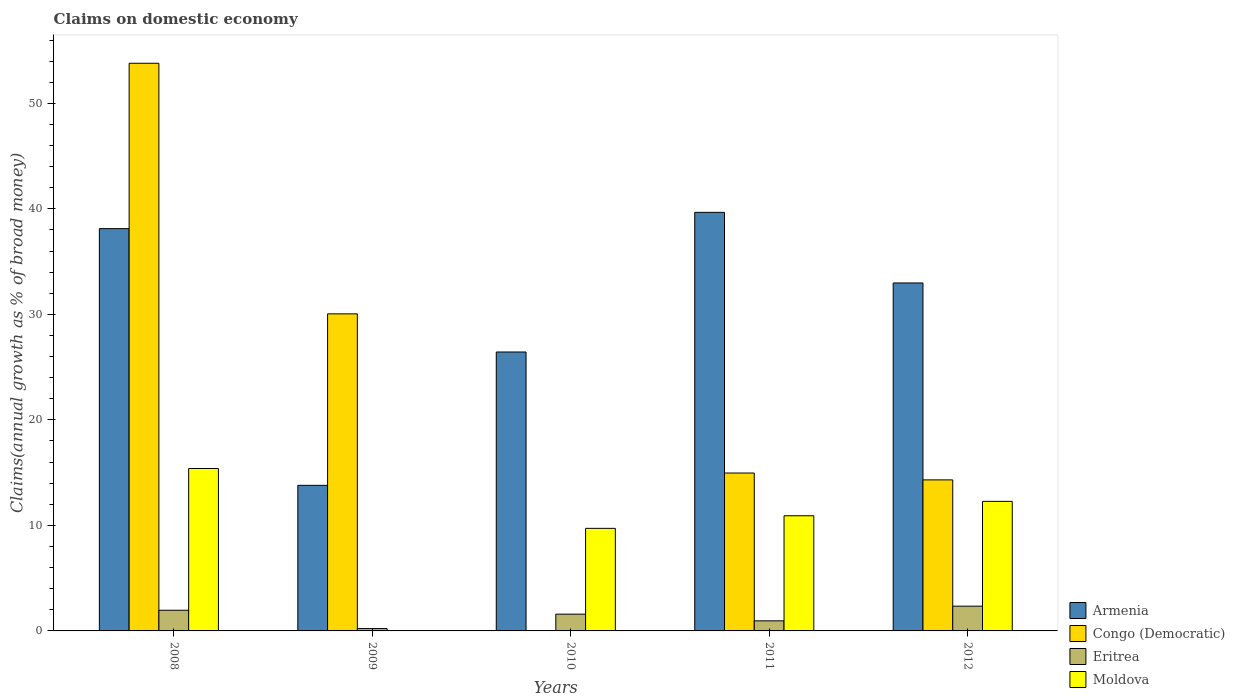Are the number of bars per tick equal to the number of legend labels?
Your answer should be compact. No. How many bars are there on the 1st tick from the left?
Provide a short and direct response. 4. How many bars are there on the 5th tick from the right?
Provide a succinct answer. 4. What is the label of the 5th group of bars from the left?
Make the answer very short. 2012. What is the percentage of broad money claimed on domestic economy in Armenia in 2010?
Keep it short and to the point. 26.43. Across all years, what is the maximum percentage of broad money claimed on domestic economy in Congo (Democratic)?
Your answer should be compact. 53.8. What is the total percentage of broad money claimed on domestic economy in Congo (Democratic) in the graph?
Offer a terse response. 113.12. What is the difference between the percentage of broad money claimed on domestic economy in Eritrea in 2009 and that in 2010?
Make the answer very short. -1.37. What is the difference between the percentage of broad money claimed on domestic economy in Moldova in 2010 and the percentage of broad money claimed on domestic economy in Eritrea in 2009?
Offer a terse response. 9.5. What is the average percentage of broad money claimed on domestic economy in Armenia per year?
Offer a very short reply. 30.2. In the year 2009, what is the difference between the percentage of broad money claimed on domestic economy in Armenia and percentage of broad money claimed on domestic economy in Congo (Democratic)?
Make the answer very short. -16.25. In how many years, is the percentage of broad money claimed on domestic economy in Eritrea greater than 46 %?
Your response must be concise. 0. What is the ratio of the percentage of broad money claimed on domestic economy in Congo (Democratic) in 2008 to that in 2011?
Offer a very short reply. 3.6. Is the percentage of broad money claimed on domestic economy in Eritrea in 2010 less than that in 2012?
Provide a succinct answer. Yes. What is the difference between the highest and the second highest percentage of broad money claimed on domestic economy in Armenia?
Make the answer very short. 1.54. What is the difference between the highest and the lowest percentage of broad money claimed on domestic economy in Eritrea?
Keep it short and to the point. 2.12. In how many years, is the percentage of broad money claimed on domestic economy in Eritrea greater than the average percentage of broad money claimed on domestic economy in Eritrea taken over all years?
Keep it short and to the point. 3. Is the sum of the percentage of broad money claimed on domestic economy in Congo (Democratic) in 2008 and 2012 greater than the maximum percentage of broad money claimed on domestic economy in Eritrea across all years?
Your answer should be very brief. Yes. Is it the case that in every year, the sum of the percentage of broad money claimed on domestic economy in Eritrea and percentage of broad money claimed on domestic economy in Moldova is greater than the sum of percentage of broad money claimed on domestic economy in Armenia and percentage of broad money claimed on domestic economy in Congo (Democratic)?
Give a very brief answer. No. Are all the bars in the graph horizontal?
Keep it short and to the point. No. What is the difference between two consecutive major ticks on the Y-axis?
Provide a succinct answer. 10. Where does the legend appear in the graph?
Give a very brief answer. Bottom right. How many legend labels are there?
Keep it short and to the point. 4. What is the title of the graph?
Give a very brief answer. Claims on domestic economy. Does "High income: OECD" appear as one of the legend labels in the graph?
Your response must be concise. No. What is the label or title of the X-axis?
Your answer should be compact. Years. What is the label or title of the Y-axis?
Make the answer very short. Claims(annual growth as % of broad money). What is the Claims(annual growth as % of broad money) of Armenia in 2008?
Give a very brief answer. 38.12. What is the Claims(annual growth as % of broad money) of Congo (Democratic) in 2008?
Keep it short and to the point. 53.8. What is the Claims(annual growth as % of broad money) of Eritrea in 2008?
Offer a very short reply. 1.96. What is the Claims(annual growth as % of broad money) of Moldova in 2008?
Provide a succinct answer. 15.39. What is the Claims(annual growth as % of broad money) of Armenia in 2009?
Offer a terse response. 13.8. What is the Claims(annual growth as % of broad money) of Congo (Democratic) in 2009?
Offer a terse response. 30.05. What is the Claims(annual growth as % of broad money) in Eritrea in 2009?
Your response must be concise. 0.22. What is the Claims(annual growth as % of broad money) in Moldova in 2009?
Ensure brevity in your answer.  0. What is the Claims(annual growth as % of broad money) in Armenia in 2010?
Your answer should be very brief. 26.43. What is the Claims(annual growth as % of broad money) in Congo (Democratic) in 2010?
Make the answer very short. 0. What is the Claims(annual growth as % of broad money) in Eritrea in 2010?
Ensure brevity in your answer.  1.59. What is the Claims(annual growth as % of broad money) of Moldova in 2010?
Offer a terse response. 9.72. What is the Claims(annual growth as % of broad money) of Armenia in 2011?
Ensure brevity in your answer.  39.67. What is the Claims(annual growth as % of broad money) of Congo (Democratic) in 2011?
Ensure brevity in your answer.  14.96. What is the Claims(annual growth as % of broad money) of Eritrea in 2011?
Keep it short and to the point. 0.96. What is the Claims(annual growth as % of broad money) in Moldova in 2011?
Give a very brief answer. 10.91. What is the Claims(annual growth as % of broad money) of Armenia in 2012?
Provide a succinct answer. 32.98. What is the Claims(annual growth as % of broad money) of Congo (Democratic) in 2012?
Your answer should be compact. 14.31. What is the Claims(annual growth as % of broad money) in Eritrea in 2012?
Make the answer very short. 2.35. What is the Claims(annual growth as % of broad money) in Moldova in 2012?
Make the answer very short. 12.28. Across all years, what is the maximum Claims(annual growth as % of broad money) in Armenia?
Provide a short and direct response. 39.67. Across all years, what is the maximum Claims(annual growth as % of broad money) of Congo (Democratic)?
Keep it short and to the point. 53.8. Across all years, what is the maximum Claims(annual growth as % of broad money) of Eritrea?
Make the answer very short. 2.35. Across all years, what is the maximum Claims(annual growth as % of broad money) in Moldova?
Your answer should be very brief. 15.39. Across all years, what is the minimum Claims(annual growth as % of broad money) of Armenia?
Make the answer very short. 13.8. Across all years, what is the minimum Claims(annual growth as % of broad money) of Congo (Democratic)?
Offer a terse response. 0. Across all years, what is the minimum Claims(annual growth as % of broad money) in Eritrea?
Offer a very short reply. 0.22. What is the total Claims(annual growth as % of broad money) in Armenia in the graph?
Your answer should be compact. 151. What is the total Claims(annual growth as % of broad money) in Congo (Democratic) in the graph?
Give a very brief answer. 113.12. What is the total Claims(annual growth as % of broad money) of Eritrea in the graph?
Your answer should be compact. 7.07. What is the total Claims(annual growth as % of broad money) in Moldova in the graph?
Keep it short and to the point. 48.3. What is the difference between the Claims(annual growth as % of broad money) of Armenia in 2008 and that in 2009?
Your answer should be very brief. 24.33. What is the difference between the Claims(annual growth as % of broad money) of Congo (Democratic) in 2008 and that in 2009?
Your answer should be compact. 23.75. What is the difference between the Claims(annual growth as % of broad money) of Eritrea in 2008 and that in 2009?
Ensure brevity in your answer.  1.74. What is the difference between the Claims(annual growth as % of broad money) in Armenia in 2008 and that in 2010?
Your answer should be very brief. 11.69. What is the difference between the Claims(annual growth as % of broad money) in Eritrea in 2008 and that in 2010?
Ensure brevity in your answer.  0.37. What is the difference between the Claims(annual growth as % of broad money) in Moldova in 2008 and that in 2010?
Make the answer very short. 5.67. What is the difference between the Claims(annual growth as % of broad money) in Armenia in 2008 and that in 2011?
Give a very brief answer. -1.54. What is the difference between the Claims(annual growth as % of broad money) in Congo (Democratic) in 2008 and that in 2011?
Ensure brevity in your answer.  38.83. What is the difference between the Claims(annual growth as % of broad money) of Moldova in 2008 and that in 2011?
Provide a succinct answer. 4.48. What is the difference between the Claims(annual growth as % of broad money) in Armenia in 2008 and that in 2012?
Your answer should be compact. 5.15. What is the difference between the Claims(annual growth as % of broad money) in Congo (Democratic) in 2008 and that in 2012?
Keep it short and to the point. 39.48. What is the difference between the Claims(annual growth as % of broad money) in Eritrea in 2008 and that in 2012?
Provide a succinct answer. -0.39. What is the difference between the Claims(annual growth as % of broad money) in Moldova in 2008 and that in 2012?
Your answer should be very brief. 3.11. What is the difference between the Claims(annual growth as % of broad money) of Armenia in 2009 and that in 2010?
Your answer should be very brief. -12.64. What is the difference between the Claims(annual growth as % of broad money) in Eritrea in 2009 and that in 2010?
Keep it short and to the point. -1.37. What is the difference between the Claims(annual growth as % of broad money) in Armenia in 2009 and that in 2011?
Give a very brief answer. -25.87. What is the difference between the Claims(annual growth as % of broad money) of Congo (Democratic) in 2009 and that in 2011?
Your answer should be very brief. 15.08. What is the difference between the Claims(annual growth as % of broad money) of Eritrea in 2009 and that in 2011?
Provide a short and direct response. -0.73. What is the difference between the Claims(annual growth as % of broad money) of Armenia in 2009 and that in 2012?
Your response must be concise. -19.18. What is the difference between the Claims(annual growth as % of broad money) of Congo (Democratic) in 2009 and that in 2012?
Give a very brief answer. 15.73. What is the difference between the Claims(annual growth as % of broad money) of Eritrea in 2009 and that in 2012?
Your answer should be very brief. -2.12. What is the difference between the Claims(annual growth as % of broad money) of Armenia in 2010 and that in 2011?
Your answer should be compact. -13.23. What is the difference between the Claims(annual growth as % of broad money) of Eritrea in 2010 and that in 2011?
Provide a short and direct response. 0.63. What is the difference between the Claims(annual growth as % of broad money) in Moldova in 2010 and that in 2011?
Your answer should be very brief. -1.19. What is the difference between the Claims(annual growth as % of broad money) in Armenia in 2010 and that in 2012?
Provide a short and direct response. -6.54. What is the difference between the Claims(annual growth as % of broad money) of Eritrea in 2010 and that in 2012?
Your answer should be compact. -0.76. What is the difference between the Claims(annual growth as % of broad money) of Moldova in 2010 and that in 2012?
Give a very brief answer. -2.56. What is the difference between the Claims(annual growth as % of broad money) in Armenia in 2011 and that in 2012?
Offer a terse response. 6.69. What is the difference between the Claims(annual growth as % of broad money) in Congo (Democratic) in 2011 and that in 2012?
Your answer should be compact. 0.65. What is the difference between the Claims(annual growth as % of broad money) of Eritrea in 2011 and that in 2012?
Make the answer very short. -1.39. What is the difference between the Claims(annual growth as % of broad money) in Moldova in 2011 and that in 2012?
Ensure brevity in your answer.  -1.36. What is the difference between the Claims(annual growth as % of broad money) in Armenia in 2008 and the Claims(annual growth as % of broad money) in Congo (Democratic) in 2009?
Your answer should be very brief. 8.08. What is the difference between the Claims(annual growth as % of broad money) in Armenia in 2008 and the Claims(annual growth as % of broad money) in Eritrea in 2009?
Provide a succinct answer. 37.9. What is the difference between the Claims(annual growth as % of broad money) of Congo (Democratic) in 2008 and the Claims(annual growth as % of broad money) of Eritrea in 2009?
Provide a short and direct response. 53.57. What is the difference between the Claims(annual growth as % of broad money) of Armenia in 2008 and the Claims(annual growth as % of broad money) of Eritrea in 2010?
Provide a short and direct response. 36.54. What is the difference between the Claims(annual growth as % of broad money) of Armenia in 2008 and the Claims(annual growth as % of broad money) of Moldova in 2010?
Make the answer very short. 28.4. What is the difference between the Claims(annual growth as % of broad money) in Congo (Democratic) in 2008 and the Claims(annual growth as % of broad money) in Eritrea in 2010?
Your answer should be very brief. 52.21. What is the difference between the Claims(annual growth as % of broad money) in Congo (Democratic) in 2008 and the Claims(annual growth as % of broad money) in Moldova in 2010?
Make the answer very short. 44.08. What is the difference between the Claims(annual growth as % of broad money) of Eritrea in 2008 and the Claims(annual growth as % of broad money) of Moldova in 2010?
Make the answer very short. -7.76. What is the difference between the Claims(annual growth as % of broad money) of Armenia in 2008 and the Claims(annual growth as % of broad money) of Congo (Democratic) in 2011?
Your response must be concise. 23.16. What is the difference between the Claims(annual growth as % of broad money) in Armenia in 2008 and the Claims(annual growth as % of broad money) in Eritrea in 2011?
Give a very brief answer. 37.17. What is the difference between the Claims(annual growth as % of broad money) of Armenia in 2008 and the Claims(annual growth as % of broad money) of Moldova in 2011?
Make the answer very short. 27.21. What is the difference between the Claims(annual growth as % of broad money) in Congo (Democratic) in 2008 and the Claims(annual growth as % of broad money) in Eritrea in 2011?
Ensure brevity in your answer.  52.84. What is the difference between the Claims(annual growth as % of broad money) of Congo (Democratic) in 2008 and the Claims(annual growth as % of broad money) of Moldova in 2011?
Offer a terse response. 42.88. What is the difference between the Claims(annual growth as % of broad money) of Eritrea in 2008 and the Claims(annual growth as % of broad money) of Moldova in 2011?
Offer a very short reply. -8.96. What is the difference between the Claims(annual growth as % of broad money) of Armenia in 2008 and the Claims(annual growth as % of broad money) of Congo (Democratic) in 2012?
Keep it short and to the point. 23.81. What is the difference between the Claims(annual growth as % of broad money) of Armenia in 2008 and the Claims(annual growth as % of broad money) of Eritrea in 2012?
Keep it short and to the point. 35.78. What is the difference between the Claims(annual growth as % of broad money) in Armenia in 2008 and the Claims(annual growth as % of broad money) in Moldova in 2012?
Keep it short and to the point. 25.85. What is the difference between the Claims(annual growth as % of broad money) in Congo (Democratic) in 2008 and the Claims(annual growth as % of broad money) in Eritrea in 2012?
Your answer should be very brief. 51.45. What is the difference between the Claims(annual growth as % of broad money) in Congo (Democratic) in 2008 and the Claims(annual growth as % of broad money) in Moldova in 2012?
Ensure brevity in your answer.  41.52. What is the difference between the Claims(annual growth as % of broad money) in Eritrea in 2008 and the Claims(annual growth as % of broad money) in Moldova in 2012?
Make the answer very short. -10.32. What is the difference between the Claims(annual growth as % of broad money) of Armenia in 2009 and the Claims(annual growth as % of broad money) of Eritrea in 2010?
Your answer should be very brief. 12.21. What is the difference between the Claims(annual growth as % of broad money) in Armenia in 2009 and the Claims(annual growth as % of broad money) in Moldova in 2010?
Keep it short and to the point. 4.08. What is the difference between the Claims(annual growth as % of broad money) of Congo (Democratic) in 2009 and the Claims(annual growth as % of broad money) of Eritrea in 2010?
Ensure brevity in your answer.  28.46. What is the difference between the Claims(annual growth as % of broad money) of Congo (Democratic) in 2009 and the Claims(annual growth as % of broad money) of Moldova in 2010?
Your answer should be compact. 20.33. What is the difference between the Claims(annual growth as % of broad money) in Eritrea in 2009 and the Claims(annual growth as % of broad money) in Moldova in 2010?
Provide a short and direct response. -9.5. What is the difference between the Claims(annual growth as % of broad money) in Armenia in 2009 and the Claims(annual growth as % of broad money) in Congo (Democratic) in 2011?
Your response must be concise. -1.17. What is the difference between the Claims(annual growth as % of broad money) of Armenia in 2009 and the Claims(annual growth as % of broad money) of Eritrea in 2011?
Your answer should be compact. 12.84. What is the difference between the Claims(annual growth as % of broad money) of Armenia in 2009 and the Claims(annual growth as % of broad money) of Moldova in 2011?
Your response must be concise. 2.88. What is the difference between the Claims(annual growth as % of broad money) of Congo (Democratic) in 2009 and the Claims(annual growth as % of broad money) of Eritrea in 2011?
Provide a short and direct response. 29.09. What is the difference between the Claims(annual growth as % of broad money) in Congo (Democratic) in 2009 and the Claims(annual growth as % of broad money) in Moldova in 2011?
Offer a very short reply. 19.13. What is the difference between the Claims(annual growth as % of broad money) of Eritrea in 2009 and the Claims(annual growth as % of broad money) of Moldova in 2011?
Provide a short and direct response. -10.69. What is the difference between the Claims(annual growth as % of broad money) in Armenia in 2009 and the Claims(annual growth as % of broad money) in Congo (Democratic) in 2012?
Offer a very short reply. -0.52. What is the difference between the Claims(annual growth as % of broad money) in Armenia in 2009 and the Claims(annual growth as % of broad money) in Eritrea in 2012?
Your response must be concise. 11.45. What is the difference between the Claims(annual growth as % of broad money) of Armenia in 2009 and the Claims(annual growth as % of broad money) of Moldova in 2012?
Your answer should be compact. 1.52. What is the difference between the Claims(annual growth as % of broad money) of Congo (Democratic) in 2009 and the Claims(annual growth as % of broad money) of Eritrea in 2012?
Your answer should be compact. 27.7. What is the difference between the Claims(annual growth as % of broad money) of Congo (Democratic) in 2009 and the Claims(annual growth as % of broad money) of Moldova in 2012?
Provide a succinct answer. 17.77. What is the difference between the Claims(annual growth as % of broad money) in Eritrea in 2009 and the Claims(annual growth as % of broad money) in Moldova in 2012?
Provide a short and direct response. -12.05. What is the difference between the Claims(annual growth as % of broad money) in Armenia in 2010 and the Claims(annual growth as % of broad money) in Congo (Democratic) in 2011?
Offer a terse response. 11.47. What is the difference between the Claims(annual growth as % of broad money) of Armenia in 2010 and the Claims(annual growth as % of broad money) of Eritrea in 2011?
Ensure brevity in your answer.  25.48. What is the difference between the Claims(annual growth as % of broad money) in Armenia in 2010 and the Claims(annual growth as % of broad money) in Moldova in 2011?
Ensure brevity in your answer.  15.52. What is the difference between the Claims(annual growth as % of broad money) in Eritrea in 2010 and the Claims(annual growth as % of broad money) in Moldova in 2011?
Ensure brevity in your answer.  -9.32. What is the difference between the Claims(annual growth as % of broad money) in Armenia in 2010 and the Claims(annual growth as % of broad money) in Congo (Democratic) in 2012?
Your answer should be very brief. 12.12. What is the difference between the Claims(annual growth as % of broad money) in Armenia in 2010 and the Claims(annual growth as % of broad money) in Eritrea in 2012?
Provide a succinct answer. 24.09. What is the difference between the Claims(annual growth as % of broad money) of Armenia in 2010 and the Claims(annual growth as % of broad money) of Moldova in 2012?
Your response must be concise. 14.16. What is the difference between the Claims(annual growth as % of broad money) in Eritrea in 2010 and the Claims(annual growth as % of broad money) in Moldova in 2012?
Your response must be concise. -10.69. What is the difference between the Claims(annual growth as % of broad money) in Armenia in 2011 and the Claims(annual growth as % of broad money) in Congo (Democratic) in 2012?
Give a very brief answer. 25.35. What is the difference between the Claims(annual growth as % of broad money) of Armenia in 2011 and the Claims(annual growth as % of broad money) of Eritrea in 2012?
Ensure brevity in your answer.  37.32. What is the difference between the Claims(annual growth as % of broad money) of Armenia in 2011 and the Claims(annual growth as % of broad money) of Moldova in 2012?
Give a very brief answer. 27.39. What is the difference between the Claims(annual growth as % of broad money) in Congo (Democratic) in 2011 and the Claims(annual growth as % of broad money) in Eritrea in 2012?
Ensure brevity in your answer.  12.62. What is the difference between the Claims(annual growth as % of broad money) of Congo (Democratic) in 2011 and the Claims(annual growth as % of broad money) of Moldova in 2012?
Your answer should be very brief. 2.69. What is the difference between the Claims(annual growth as % of broad money) of Eritrea in 2011 and the Claims(annual growth as % of broad money) of Moldova in 2012?
Your response must be concise. -11.32. What is the average Claims(annual growth as % of broad money) in Armenia per year?
Provide a short and direct response. 30.2. What is the average Claims(annual growth as % of broad money) in Congo (Democratic) per year?
Provide a succinct answer. 22.62. What is the average Claims(annual growth as % of broad money) of Eritrea per year?
Offer a very short reply. 1.41. What is the average Claims(annual growth as % of broad money) in Moldova per year?
Provide a short and direct response. 9.66. In the year 2008, what is the difference between the Claims(annual growth as % of broad money) of Armenia and Claims(annual growth as % of broad money) of Congo (Democratic)?
Provide a short and direct response. -15.67. In the year 2008, what is the difference between the Claims(annual growth as % of broad money) of Armenia and Claims(annual growth as % of broad money) of Eritrea?
Offer a terse response. 36.17. In the year 2008, what is the difference between the Claims(annual growth as % of broad money) of Armenia and Claims(annual growth as % of broad money) of Moldova?
Your answer should be compact. 22.73. In the year 2008, what is the difference between the Claims(annual growth as % of broad money) in Congo (Democratic) and Claims(annual growth as % of broad money) in Eritrea?
Ensure brevity in your answer.  51.84. In the year 2008, what is the difference between the Claims(annual growth as % of broad money) of Congo (Democratic) and Claims(annual growth as % of broad money) of Moldova?
Your answer should be very brief. 38.41. In the year 2008, what is the difference between the Claims(annual growth as % of broad money) of Eritrea and Claims(annual growth as % of broad money) of Moldova?
Provide a short and direct response. -13.43. In the year 2009, what is the difference between the Claims(annual growth as % of broad money) in Armenia and Claims(annual growth as % of broad money) in Congo (Democratic)?
Ensure brevity in your answer.  -16.25. In the year 2009, what is the difference between the Claims(annual growth as % of broad money) in Armenia and Claims(annual growth as % of broad money) in Eritrea?
Offer a terse response. 13.57. In the year 2009, what is the difference between the Claims(annual growth as % of broad money) in Congo (Democratic) and Claims(annual growth as % of broad money) in Eritrea?
Your answer should be very brief. 29.82. In the year 2010, what is the difference between the Claims(annual growth as % of broad money) in Armenia and Claims(annual growth as % of broad money) in Eritrea?
Your response must be concise. 24.84. In the year 2010, what is the difference between the Claims(annual growth as % of broad money) of Armenia and Claims(annual growth as % of broad money) of Moldova?
Your answer should be compact. 16.71. In the year 2010, what is the difference between the Claims(annual growth as % of broad money) in Eritrea and Claims(annual growth as % of broad money) in Moldova?
Offer a terse response. -8.13. In the year 2011, what is the difference between the Claims(annual growth as % of broad money) of Armenia and Claims(annual growth as % of broad money) of Congo (Democratic)?
Your answer should be very brief. 24.7. In the year 2011, what is the difference between the Claims(annual growth as % of broad money) in Armenia and Claims(annual growth as % of broad money) in Eritrea?
Keep it short and to the point. 38.71. In the year 2011, what is the difference between the Claims(annual growth as % of broad money) of Armenia and Claims(annual growth as % of broad money) of Moldova?
Your response must be concise. 28.75. In the year 2011, what is the difference between the Claims(annual growth as % of broad money) in Congo (Democratic) and Claims(annual growth as % of broad money) in Eritrea?
Provide a short and direct response. 14.01. In the year 2011, what is the difference between the Claims(annual growth as % of broad money) in Congo (Democratic) and Claims(annual growth as % of broad money) in Moldova?
Your answer should be compact. 4.05. In the year 2011, what is the difference between the Claims(annual growth as % of broad money) of Eritrea and Claims(annual growth as % of broad money) of Moldova?
Your response must be concise. -9.96. In the year 2012, what is the difference between the Claims(annual growth as % of broad money) in Armenia and Claims(annual growth as % of broad money) in Congo (Democratic)?
Give a very brief answer. 18.66. In the year 2012, what is the difference between the Claims(annual growth as % of broad money) of Armenia and Claims(annual growth as % of broad money) of Eritrea?
Your response must be concise. 30.63. In the year 2012, what is the difference between the Claims(annual growth as % of broad money) of Armenia and Claims(annual growth as % of broad money) of Moldova?
Give a very brief answer. 20.7. In the year 2012, what is the difference between the Claims(annual growth as % of broad money) of Congo (Democratic) and Claims(annual growth as % of broad money) of Eritrea?
Ensure brevity in your answer.  11.97. In the year 2012, what is the difference between the Claims(annual growth as % of broad money) of Congo (Democratic) and Claims(annual growth as % of broad money) of Moldova?
Offer a very short reply. 2.04. In the year 2012, what is the difference between the Claims(annual growth as % of broad money) in Eritrea and Claims(annual growth as % of broad money) in Moldova?
Give a very brief answer. -9.93. What is the ratio of the Claims(annual growth as % of broad money) in Armenia in 2008 to that in 2009?
Keep it short and to the point. 2.76. What is the ratio of the Claims(annual growth as % of broad money) of Congo (Democratic) in 2008 to that in 2009?
Ensure brevity in your answer.  1.79. What is the ratio of the Claims(annual growth as % of broad money) of Eritrea in 2008 to that in 2009?
Give a very brief answer. 8.77. What is the ratio of the Claims(annual growth as % of broad money) of Armenia in 2008 to that in 2010?
Provide a short and direct response. 1.44. What is the ratio of the Claims(annual growth as % of broad money) in Eritrea in 2008 to that in 2010?
Provide a short and direct response. 1.23. What is the ratio of the Claims(annual growth as % of broad money) of Moldova in 2008 to that in 2010?
Provide a short and direct response. 1.58. What is the ratio of the Claims(annual growth as % of broad money) in Armenia in 2008 to that in 2011?
Your answer should be compact. 0.96. What is the ratio of the Claims(annual growth as % of broad money) in Congo (Democratic) in 2008 to that in 2011?
Your answer should be compact. 3.6. What is the ratio of the Claims(annual growth as % of broad money) in Eritrea in 2008 to that in 2011?
Your answer should be very brief. 2.05. What is the ratio of the Claims(annual growth as % of broad money) in Moldova in 2008 to that in 2011?
Keep it short and to the point. 1.41. What is the ratio of the Claims(annual growth as % of broad money) of Armenia in 2008 to that in 2012?
Offer a terse response. 1.16. What is the ratio of the Claims(annual growth as % of broad money) in Congo (Democratic) in 2008 to that in 2012?
Offer a terse response. 3.76. What is the ratio of the Claims(annual growth as % of broad money) of Eritrea in 2008 to that in 2012?
Your answer should be very brief. 0.83. What is the ratio of the Claims(annual growth as % of broad money) of Moldova in 2008 to that in 2012?
Your answer should be very brief. 1.25. What is the ratio of the Claims(annual growth as % of broad money) of Armenia in 2009 to that in 2010?
Your response must be concise. 0.52. What is the ratio of the Claims(annual growth as % of broad money) of Eritrea in 2009 to that in 2010?
Your response must be concise. 0.14. What is the ratio of the Claims(annual growth as % of broad money) of Armenia in 2009 to that in 2011?
Keep it short and to the point. 0.35. What is the ratio of the Claims(annual growth as % of broad money) in Congo (Democratic) in 2009 to that in 2011?
Provide a succinct answer. 2.01. What is the ratio of the Claims(annual growth as % of broad money) of Eritrea in 2009 to that in 2011?
Keep it short and to the point. 0.23. What is the ratio of the Claims(annual growth as % of broad money) in Armenia in 2009 to that in 2012?
Keep it short and to the point. 0.42. What is the ratio of the Claims(annual growth as % of broad money) of Congo (Democratic) in 2009 to that in 2012?
Keep it short and to the point. 2.1. What is the ratio of the Claims(annual growth as % of broad money) of Eritrea in 2009 to that in 2012?
Ensure brevity in your answer.  0.1. What is the ratio of the Claims(annual growth as % of broad money) of Armenia in 2010 to that in 2011?
Give a very brief answer. 0.67. What is the ratio of the Claims(annual growth as % of broad money) in Eritrea in 2010 to that in 2011?
Keep it short and to the point. 1.66. What is the ratio of the Claims(annual growth as % of broad money) of Moldova in 2010 to that in 2011?
Your response must be concise. 0.89. What is the ratio of the Claims(annual growth as % of broad money) of Armenia in 2010 to that in 2012?
Provide a succinct answer. 0.8. What is the ratio of the Claims(annual growth as % of broad money) of Eritrea in 2010 to that in 2012?
Provide a short and direct response. 0.68. What is the ratio of the Claims(annual growth as % of broad money) in Moldova in 2010 to that in 2012?
Offer a terse response. 0.79. What is the ratio of the Claims(annual growth as % of broad money) of Armenia in 2011 to that in 2012?
Make the answer very short. 1.2. What is the ratio of the Claims(annual growth as % of broad money) of Congo (Democratic) in 2011 to that in 2012?
Provide a short and direct response. 1.05. What is the ratio of the Claims(annual growth as % of broad money) of Eritrea in 2011 to that in 2012?
Make the answer very short. 0.41. What is the ratio of the Claims(annual growth as % of broad money) of Moldova in 2011 to that in 2012?
Your answer should be very brief. 0.89. What is the difference between the highest and the second highest Claims(annual growth as % of broad money) of Armenia?
Your answer should be very brief. 1.54. What is the difference between the highest and the second highest Claims(annual growth as % of broad money) in Congo (Democratic)?
Give a very brief answer. 23.75. What is the difference between the highest and the second highest Claims(annual growth as % of broad money) in Eritrea?
Provide a short and direct response. 0.39. What is the difference between the highest and the second highest Claims(annual growth as % of broad money) of Moldova?
Your answer should be compact. 3.11. What is the difference between the highest and the lowest Claims(annual growth as % of broad money) of Armenia?
Keep it short and to the point. 25.87. What is the difference between the highest and the lowest Claims(annual growth as % of broad money) in Congo (Democratic)?
Ensure brevity in your answer.  53.8. What is the difference between the highest and the lowest Claims(annual growth as % of broad money) of Eritrea?
Ensure brevity in your answer.  2.12. What is the difference between the highest and the lowest Claims(annual growth as % of broad money) of Moldova?
Your answer should be very brief. 15.39. 